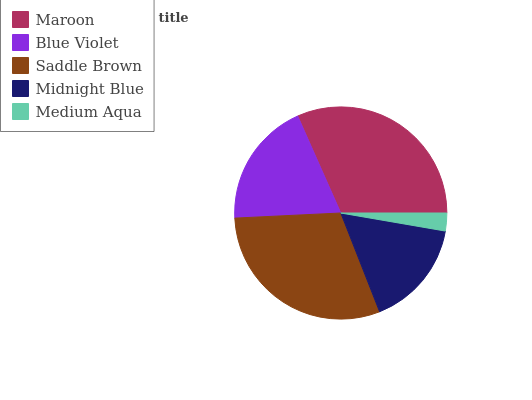Is Medium Aqua the minimum?
Answer yes or no. Yes. Is Maroon the maximum?
Answer yes or no. Yes. Is Blue Violet the minimum?
Answer yes or no. No. Is Blue Violet the maximum?
Answer yes or no. No. Is Maroon greater than Blue Violet?
Answer yes or no. Yes. Is Blue Violet less than Maroon?
Answer yes or no. Yes. Is Blue Violet greater than Maroon?
Answer yes or no. No. Is Maroon less than Blue Violet?
Answer yes or no. No. Is Blue Violet the high median?
Answer yes or no. Yes. Is Blue Violet the low median?
Answer yes or no. Yes. Is Maroon the high median?
Answer yes or no. No. Is Medium Aqua the low median?
Answer yes or no. No. 